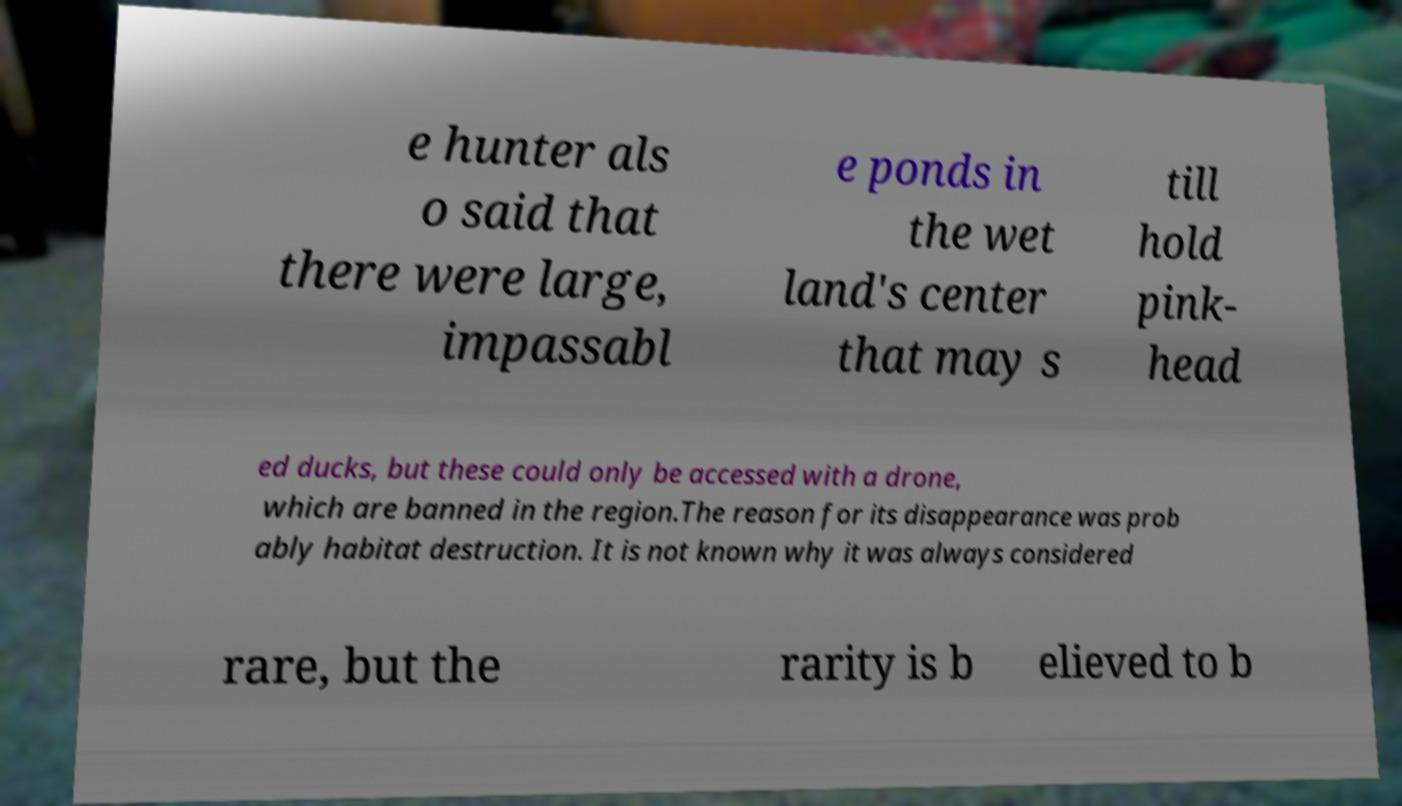Could you extract and type out the text from this image? e hunter als o said that there were large, impassabl e ponds in the wet land's center that may s till hold pink- head ed ducks, but these could only be accessed with a drone, which are banned in the region.The reason for its disappearance was prob ably habitat destruction. It is not known why it was always considered rare, but the rarity is b elieved to b 